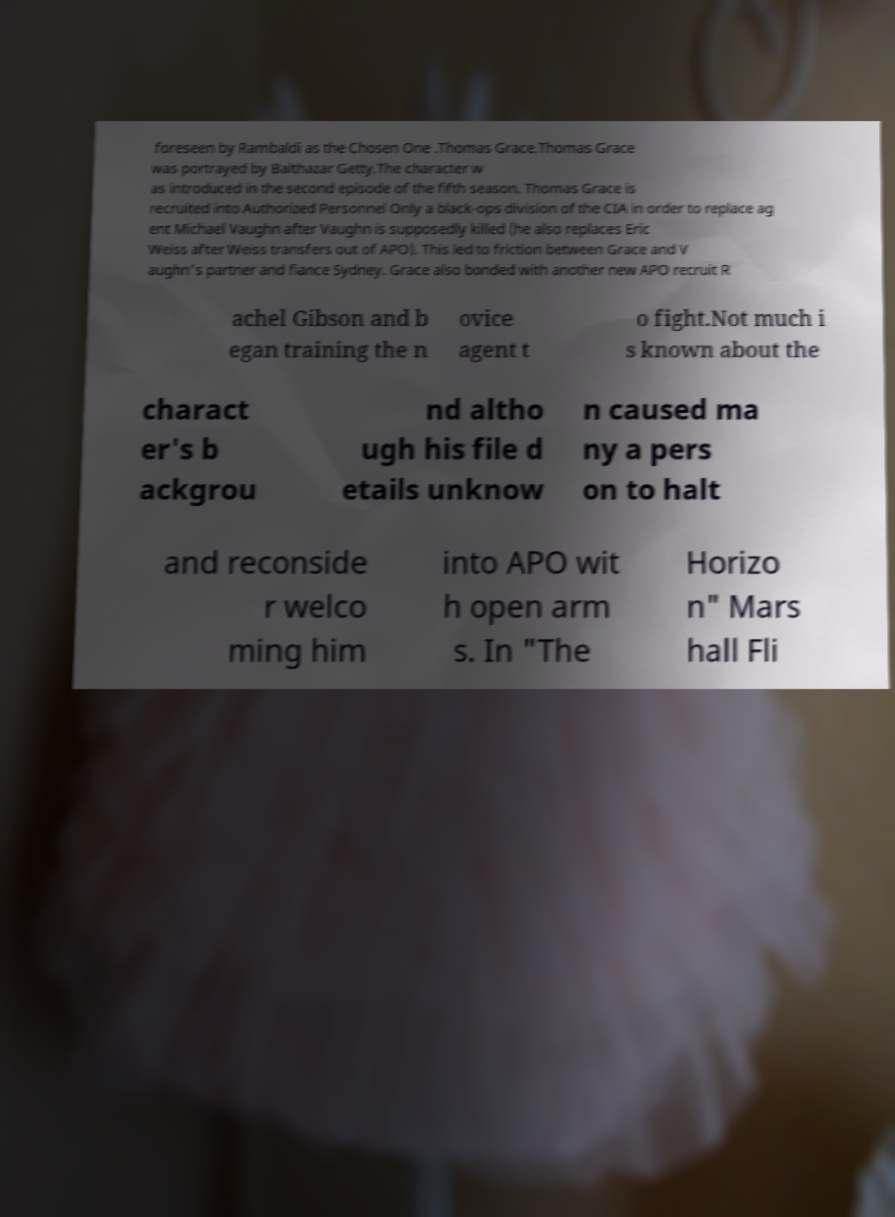Can you accurately transcribe the text from the provided image for me? foreseen by Rambaldi as the Chosen One .Thomas Grace.Thomas Grace was portrayed by Balthazar Getty.The character w as introduced in the second episode of the fifth season. Thomas Grace is recruited into Authorized Personnel Only a black-ops division of the CIA in order to replace ag ent Michael Vaughn after Vaughn is supposedly killed (he also replaces Eric Weiss after Weiss transfers out of APO). This led to friction between Grace and V aughn's partner and fiance Sydney. Grace also bonded with another new APO recruit R achel Gibson and b egan training the n ovice agent t o fight.Not much i s known about the charact er's b ackgrou nd altho ugh his file d etails unknow n caused ma ny a pers on to halt and reconside r welco ming him into APO wit h open arm s. In "The Horizo n" Mars hall Fli 